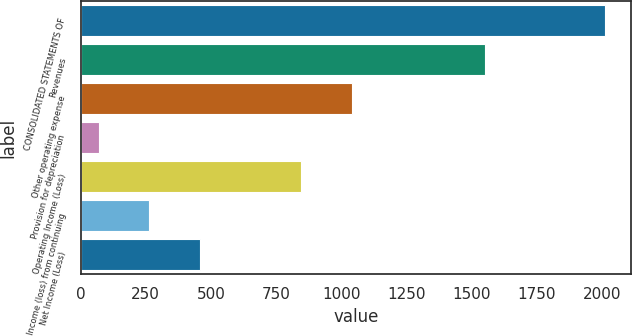<chart> <loc_0><loc_0><loc_500><loc_500><bar_chart><fcel>CONSOLIDATED STATEMENTS OF<fcel>Revenues<fcel>Other operating expense<fcel>Provision for depreciation<fcel>Operating Income (Loss)<fcel>Income (loss) from continuing<fcel>Net Income (Loss)<nl><fcel>2012<fcel>1550<fcel>1041<fcel>70<fcel>846.8<fcel>264.2<fcel>458.4<nl></chart> 